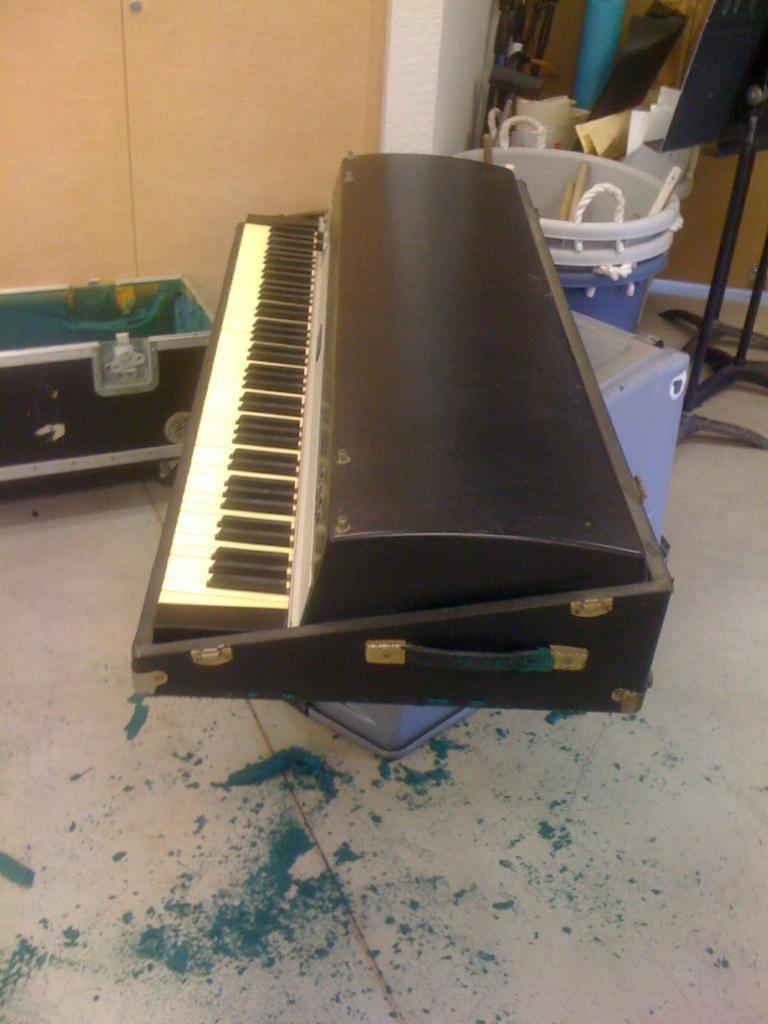In one or two sentences, can you explain what this image depicts? In this image there is a piano in the center. Towards the left there is a trunk, towards the right there are buckets, boards and stands. 